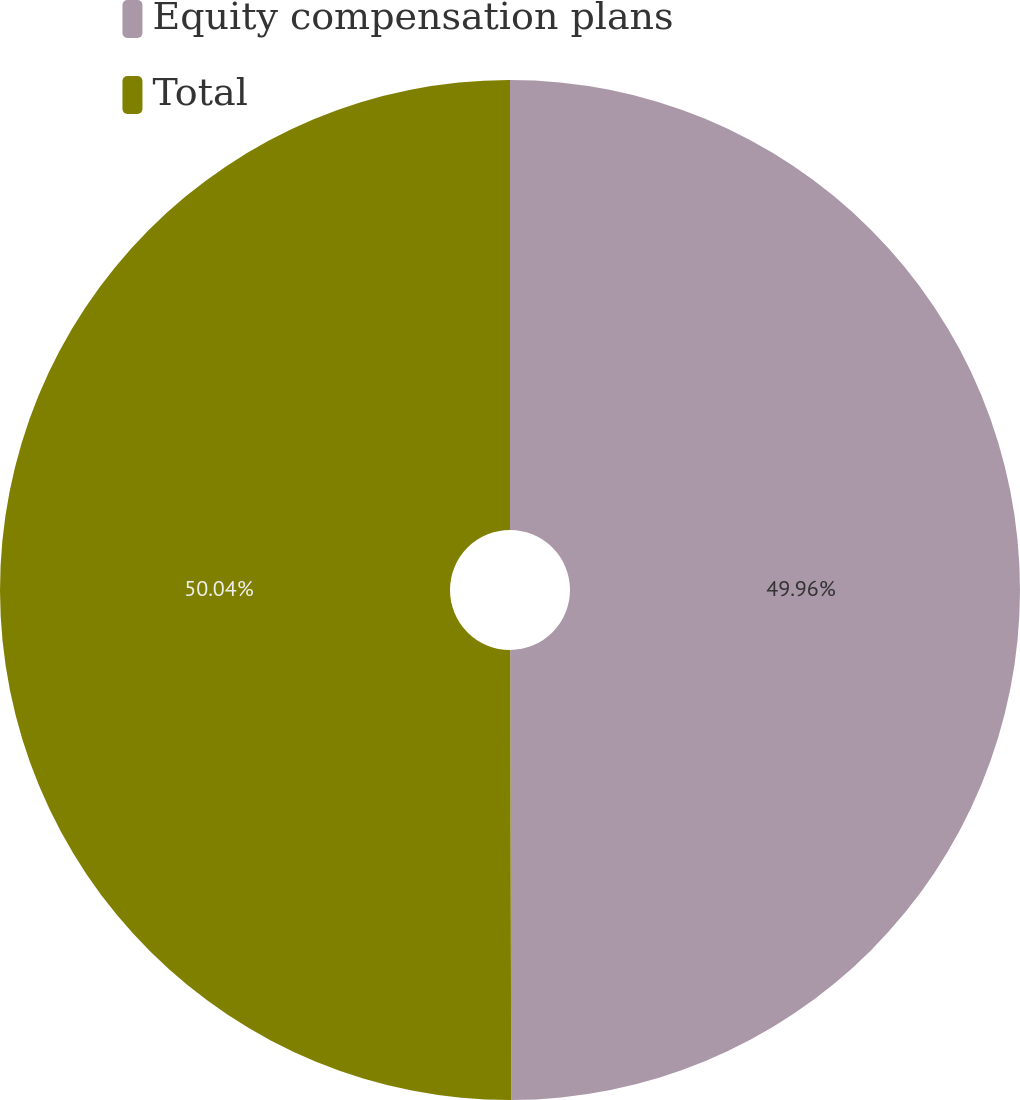Convert chart to OTSL. <chart><loc_0><loc_0><loc_500><loc_500><pie_chart><fcel>Equity compensation plans<fcel>Total<nl><fcel>49.96%<fcel>50.04%<nl></chart> 